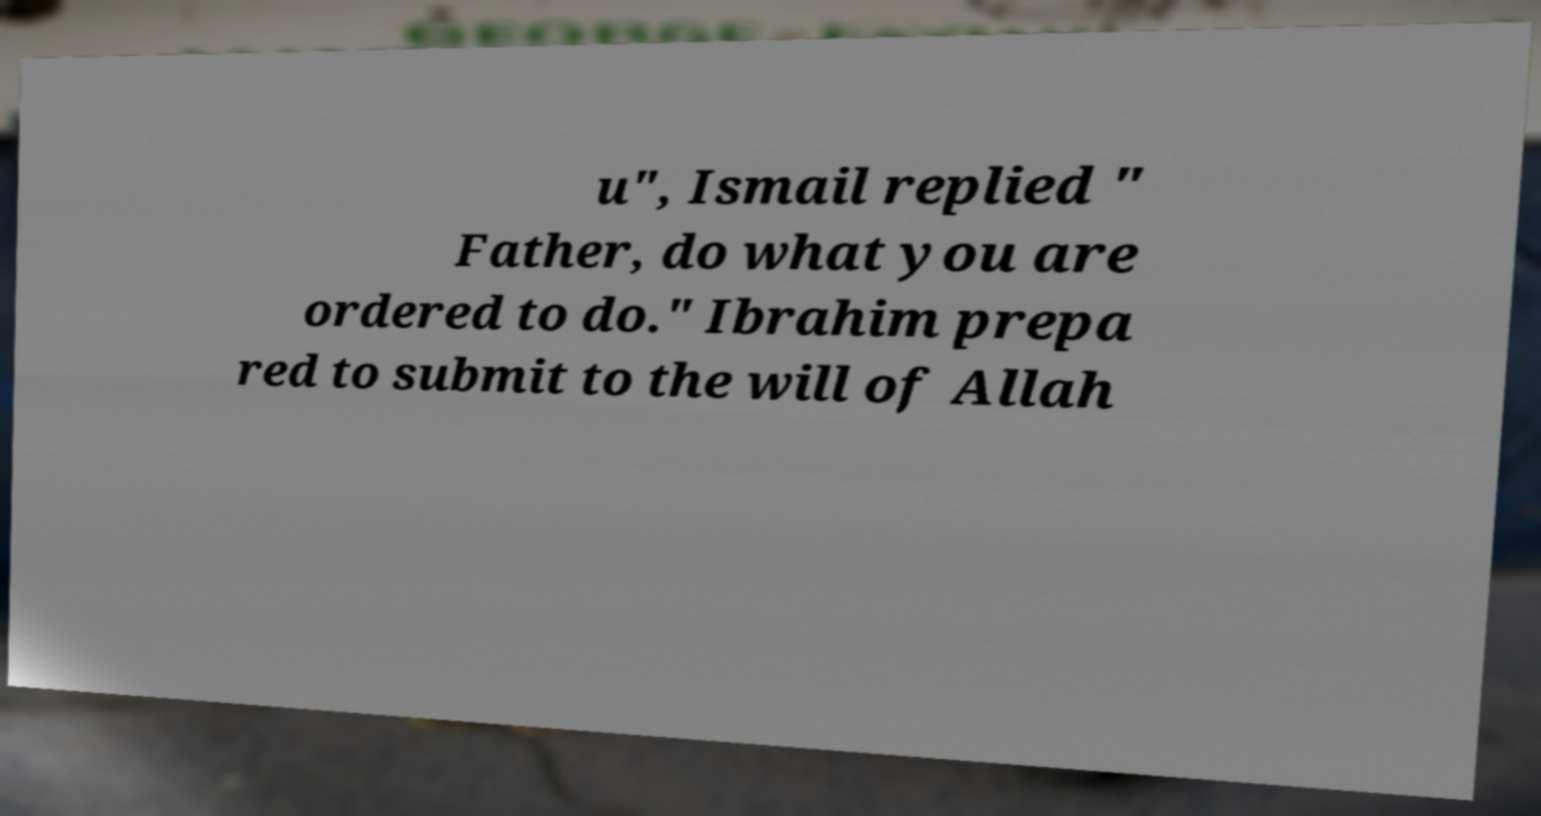I need the written content from this picture converted into text. Can you do that? u", Ismail replied " Father, do what you are ordered to do." Ibrahim prepa red to submit to the will of Allah 